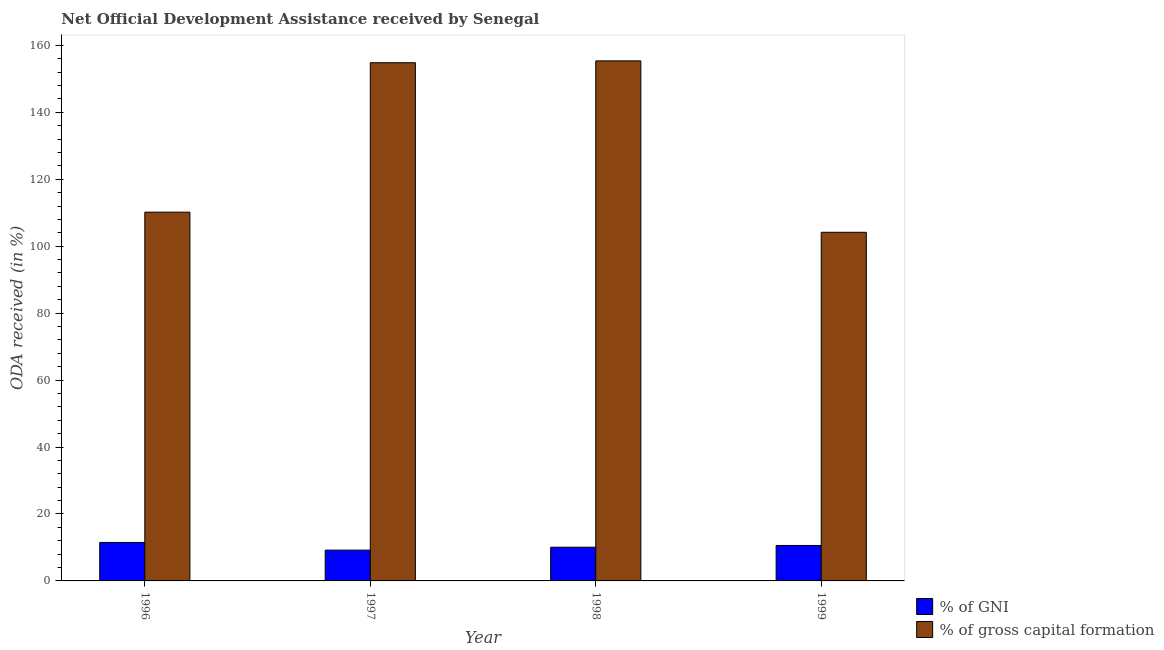How many groups of bars are there?
Make the answer very short. 4. In how many cases, is the number of bars for a given year not equal to the number of legend labels?
Provide a short and direct response. 0. What is the oda received as percentage of gross capital formation in 1996?
Offer a very short reply. 110.17. Across all years, what is the maximum oda received as percentage of gni?
Offer a terse response. 11.49. Across all years, what is the minimum oda received as percentage of gni?
Keep it short and to the point. 9.2. In which year was the oda received as percentage of gni maximum?
Your response must be concise. 1996. What is the total oda received as percentage of gross capital formation in the graph?
Ensure brevity in your answer.  524.52. What is the difference between the oda received as percentage of gni in 1996 and that in 1997?
Keep it short and to the point. 2.3. What is the difference between the oda received as percentage of gross capital formation in 1996 and the oda received as percentage of gni in 1999?
Provide a short and direct response. 6.01. What is the average oda received as percentage of gni per year?
Provide a short and direct response. 10.34. What is the ratio of the oda received as percentage of gni in 1997 to that in 1998?
Offer a terse response. 0.91. Is the oda received as percentage of gross capital formation in 1996 less than that in 1997?
Provide a short and direct response. Yes. Is the difference between the oda received as percentage of gni in 1998 and 1999 greater than the difference between the oda received as percentage of gross capital formation in 1998 and 1999?
Your answer should be compact. No. What is the difference between the highest and the second highest oda received as percentage of gross capital formation?
Ensure brevity in your answer.  0.55. What is the difference between the highest and the lowest oda received as percentage of gross capital formation?
Your response must be concise. 51.21. Is the sum of the oda received as percentage of gross capital formation in 1997 and 1998 greater than the maximum oda received as percentage of gni across all years?
Give a very brief answer. Yes. What does the 2nd bar from the left in 1997 represents?
Keep it short and to the point. % of gross capital formation. What does the 1st bar from the right in 1999 represents?
Provide a short and direct response. % of gross capital formation. Are the values on the major ticks of Y-axis written in scientific E-notation?
Offer a terse response. No. Does the graph contain any zero values?
Ensure brevity in your answer.  No. Does the graph contain grids?
Offer a very short reply. No. How many legend labels are there?
Provide a succinct answer. 2. How are the legend labels stacked?
Offer a very short reply. Vertical. What is the title of the graph?
Your response must be concise. Net Official Development Assistance received by Senegal. Does "Electricity" appear as one of the legend labels in the graph?
Give a very brief answer. No. What is the label or title of the X-axis?
Your answer should be very brief. Year. What is the label or title of the Y-axis?
Keep it short and to the point. ODA received (in %). What is the ODA received (in %) in % of GNI in 1996?
Give a very brief answer. 11.49. What is the ODA received (in %) of % of gross capital formation in 1996?
Your response must be concise. 110.17. What is the ODA received (in %) of % of GNI in 1997?
Your answer should be very brief. 9.2. What is the ODA received (in %) in % of gross capital formation in 1997?
Ensure brevity in your answer.  154.82. What is the ODA received (in %) in % of GNI in 1998?
Ensure brevity in your answer.  10.07. What is the ODA received (in %) in % of gross capital formation in 1998?
Ensure brevity in your answer.  155.37. What is the ODA received (in %) in % of GNI in 1999?
Provide a succinct answer. 10.59. What is the ODA received (in %) of % of gross capital formation in 1999?
Give a very brief answer. 104.16. Across all years, what is the maximum ODA received (in %) in % of GNI?
Provide a short and direct response. 11.49. Across all years, what is the maximum ODA received (in %) of % of gross capital formation?
Offer a very short reply. 155.37. Across all years, what is the minimum ODA received (in %) in % of GNI?
Give a very brief answer. 9.2. Across all years, what is the minimum ODA received (in %) of % of gross capital formation?
Your answer should be compact. 104.16. What is the total ODA received (in %) of % of GNI in the graph?
Provide a short and direct response. 41.35. What is the total ODA received (in %) in % of gross capital formation in the graph?
Ensure brevity in your answer.  524.52. What is the difference between the ODA received (in %) of % of GNI in 1996 and that in 1997?
Your answer should be compact. 2.3. What is the difference between the ODA received (in %) of % of gross capital formation in 1996 and that in 1997?
Your answer should be compact. -44.65. What is the difference between the ODA received (in %) of % of GNI in 1996 and that in 1998?
Give a very brief answer. 1.42. What is the difference between the ODA received (in %) of % of gross capital formation in 1996 and that in 1998?
Offer a terse response. -45.2. What is the difference between the ODA received (in %) in % of GNI in 1996 and that in 1999?
Keep it short and to the point. 0.9. What is the difference between the ODA received (in %) of % of gross capital formation in 1996 and that in 1999?
Your response must be concise. 6.01. What is the difference between the ODA received (in %) of % of GNI in 1997 and that in 1998?
Ensure brevity in your answer.  -0.87. What is the difference between the ODA received (in %) of % of gross capital formation in 1997 and that in 1998?
Offer a terse response. -0.55. What is the difference between the ODA received (in %) in % of GNI in 1997 and that in 1999?
Offer a very short reply. -1.39. What is the difference between the ODA received (in %) of % of gross capital formation in 1997 and that in 1999?
Offer a very short reply. 50.66. What is the difference between the ODA received (in %) in % of GNI in 1998 and that in 1999?
Keep it short and to the point. -0.52. What is the difference between the ODA received (in %) in % of gross capital formation in 1998 and that in 1999?
Your answer should be very brief. 51.21. What is the difference between the ODA received (in %) of % of GNI in 1996 and the ODA received (in %) of % of gross capital formation in 1997?
Provide a succinct answer. -143.33. What is the difference between the ODA received (in %) in % of GNI in 1996 and the ODA received (in %) in % of gross capital formation in 1998?
Your answer should be compact. -143.88. What is the difference between the ODA received (in %) in % of GNI in 1996 and the ODA received (in %) in % of gross capital formation in 1999?
Your answer should be very brief. -92.67. What is the difference between the ODA received (in %) in % of GNI in 1997 and the ODA received (in %) in % of gross capital formation in 1998?
Offer a very short reply. -146.17. What is the difference between the ODA received (in %) of % of GNI in 1997 and the ODA received (in %) of % of gross capital formation in 1999?
Ensure brevity in your answer.  -94.96. What is the difference between the ODA received (in %) of % of GNI in 1998 and the ODA received (in %) of % of gross capital formation in 1999?
Ensure brevity in your answer.  -94.09. What is the average ODA received (in %) in % of GNI per year?
Keep it short and to the point. 10.34. What is the average ODA received (in %) of % of gross capital formation per year?
Provide a short and direct response. 131.13. In the year 1996, what is the difference between the ODA received (in %) in % of GNI and ODA received (in %) in % of gross capital formation?
Offer a very short reply. -98.68. In the year 1997, what is the difference between the ODA received (in %) in % of GNI and ODA received (in %) in % of gross capital formation?
Your answer should be compact. -145.62. In the year 1998, what is the difference between the ODA received (in %) of % of GNI and ODA received (in %) of % of gross capital formation?
Provide a short and direct response. -145.3. In the year 1999, what is the difference between the ODA received (in %) in % of GNI and ODA received (in %) in % of gross capital formation?
Keep it short and to the point. -93.57. What is the ratio of the ODA received (in %) of % of GNI in 1996 to that in 1997?
Ensure brevity in your answer.  1.25. What is the ratio of the ODA received (in %) in % of gross capital formation in 1996 to that in 1997?
Offer a terse response. 0.71. What is the ratio of the ODA received (in %) in % of GNI in 1996 to that in 1998?
Your answer should be very brief. 1.14. What is the ratio of the ODA received (in %) of % of gross capital formation in 1996 to that in 1998?
Your response must be concise. 0.71. What is the ratio of the ODA received (in %) in % of GNI in 1996 to that in 1999?
Keep it short and to the point. 1.09. What is the ratio of the ODA received (in %) of % of gross capital formation in 1996 to that in 1999?
Ensure brevity in your answer.  1.06. What is the ratio of the ODA received (in %) in % of GNI in 1997 to that in 1998?
Keep it short and to the point. 0.91. What is the ratio of the ODA received (in %) of % of GNI in 1997 to that in 1999?
Your answer should be compact. 0.87. What is the ratio of the ODA received (in %) of % of gross capital formation in 1997 to that in 1999?
Give a very brief answer. 1.49. What is the ratio of the ODA received (in %) in % of GNI in 1998 to that in 1999?
Provide a succinct answer. 0.95. What is the ratio of the ODA received (in %) in % of gross capital formation in 1998 to that in 1999?
Your answer should be compact. 1.49. What is the difference between the highest and the second highest ODA received (in %) in % of GNI?
Keep it short and to the point. 0.9. What is the difference between the highest and the second highest ODA received (in %) of % of gross capital formation?
Offer a terse response. 0.55. What is the difference between the highest and the lowest ODA received (in %) of % of GNI?
Provide a succinct answer. 2.3. What is the difference between the highest and the lowest ODA received (in %) in % of gross capital formation?
Provide a succinct answer. 51.21. 